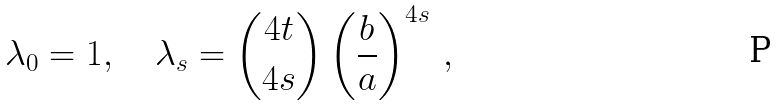<formula> <loc_0><loc_0><loc_500><loc_500>\lambda _ { 0 } = 1 , \quad \lambda _ { s } = \binom { 4 t } { 4 s } \left ( \frac { b } { a } \right ) ^ { 4 s } \, ,</formula> 